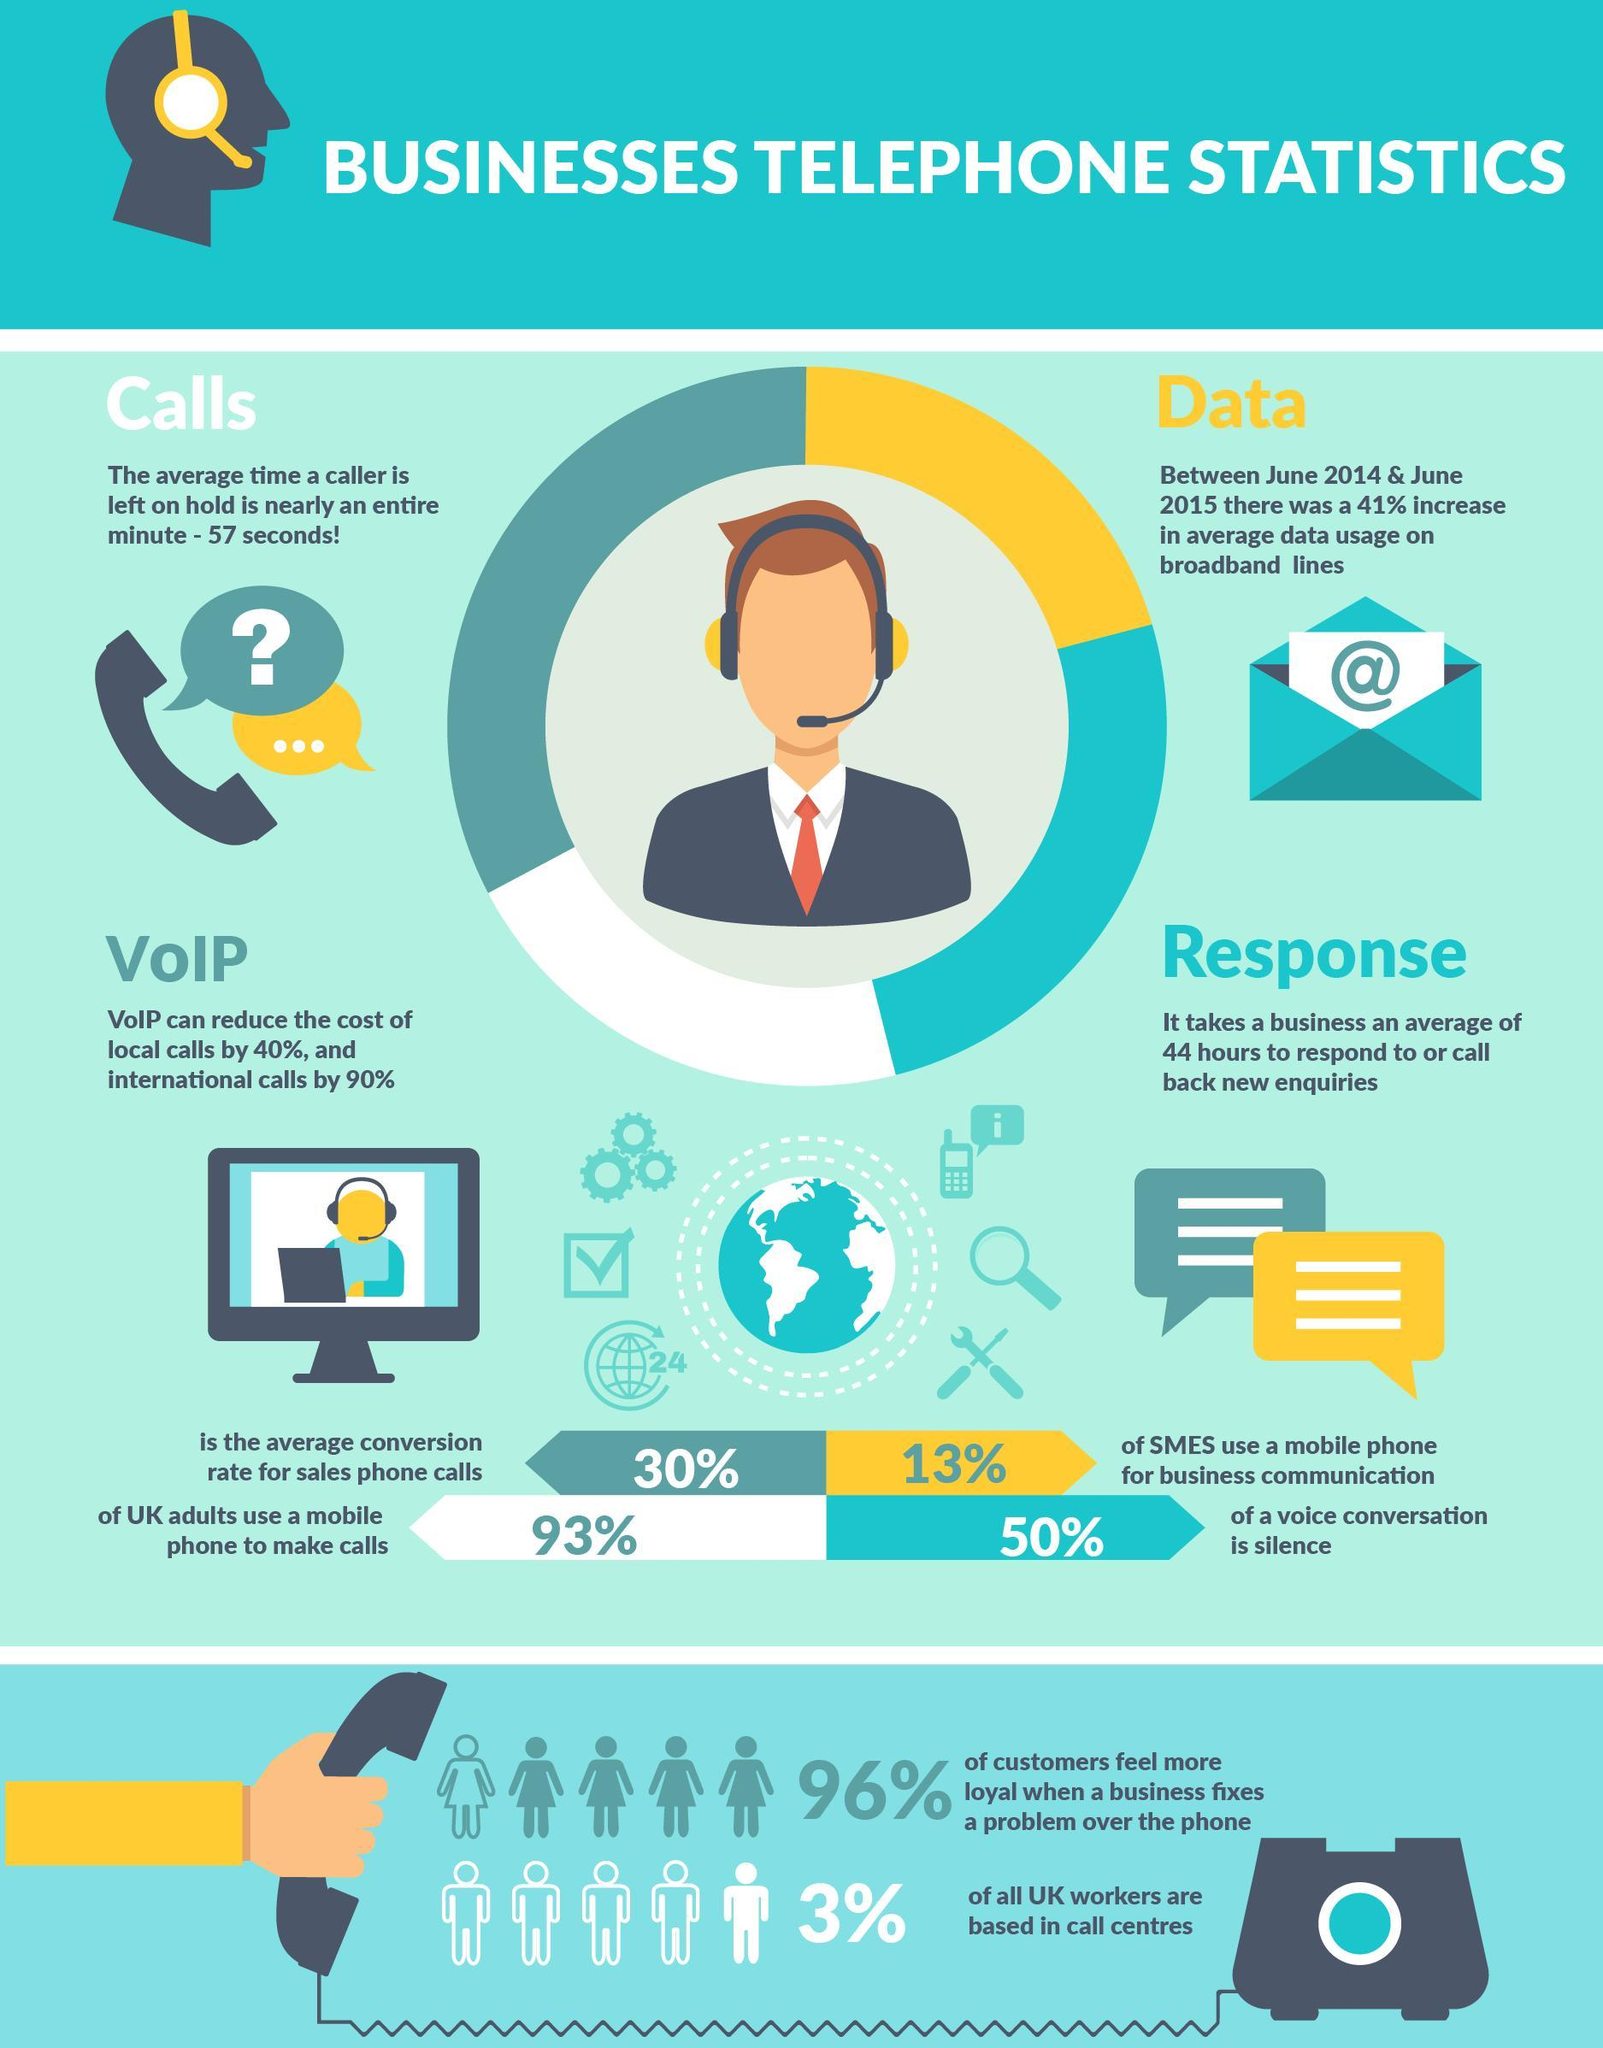What percentage of all UK workers are not based in call centres?
Answer the question with a short phrase. 97% What percentage of SMEs in UK do not use a mobile phone for business communication? 87% What percentage of customers in UK don't feel loyal when a business fixes a problem over the phone? 4% 